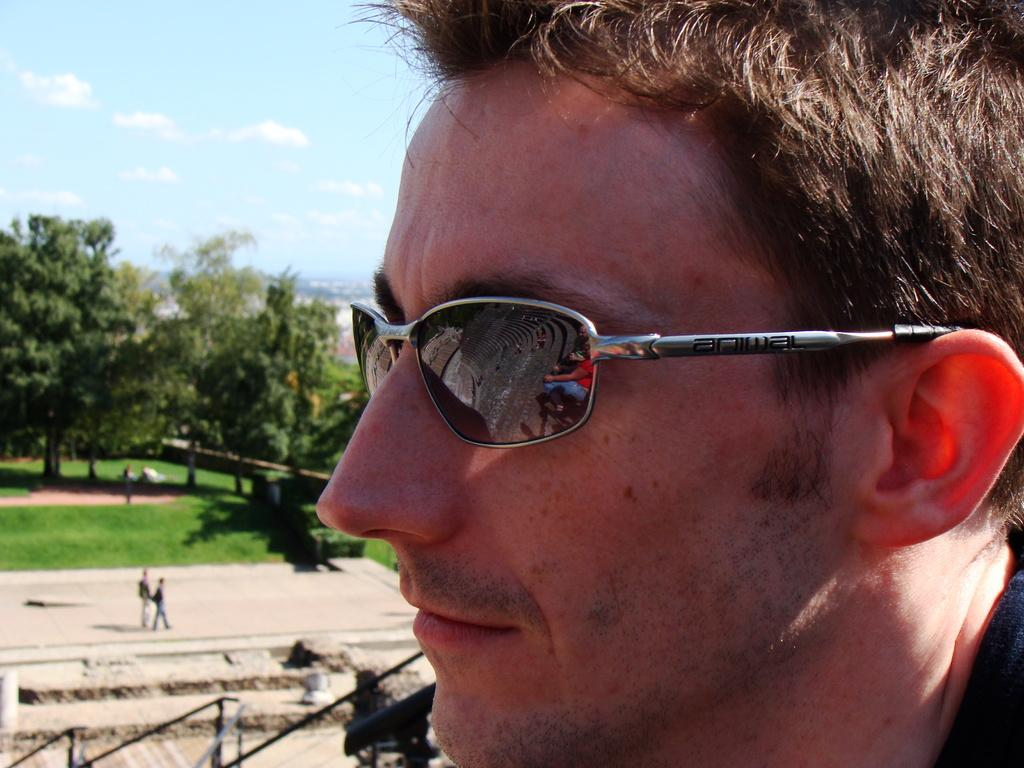What is the man in the image wearing on his face? The man is wearing goggles in the image. How many people are on the ground in the image? There are two people on the ground in the image. What can be seen in the image that separates areas or provides a boundary? There is a fence in the image. What type of vegetation is present in the image? There are trees and grass in the image. What else can be seen in the image besides the people, fence, and vegetation? There are some unspecified objects in the image. What is visible in the background of the image? The sky with clouds is visible in the background of the image. What time of day is it in the image, and what season is it? The time of day and season are not specified in the image. What type of memory is the man trying to recall in the image? There is no indication in the image that the man is trying to recall a memory. 